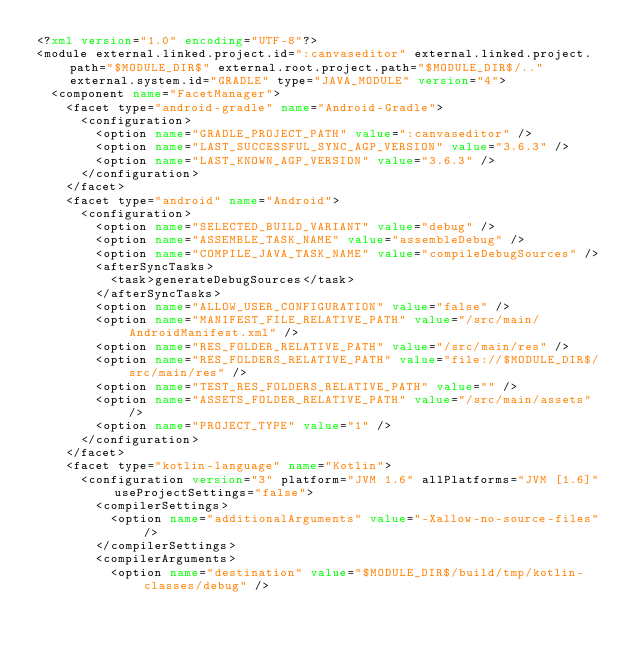Convert code to text. <code><loc_0><loc_0><loc_500><loc_500><_XML_><?xml version="1.0" encoding="UTF-8"?>
<module external.linked.project.id=":canvaseditor" external.linked.project.path="$MODULE_DIR$" external.root.project.path="$MODULE_DIR$/.." external.system.id="GRADLE" type="JAVA_MODULE" version="4">
  <component name="FacetManager">
    <facet type="android-gradle" name="Android-Gradle">
      <configuration>
        <option name="GRADLE_PROJECT_PATH" value=":canvaseditor" />
        <option name="LAST_SUCCESSFUL_SYNC_AGP_VERSION" value="3.6.3" />
        <option name="LAST_KNOWN_AGP_VERSION" value="3.6.3" />
      </configuration>
    </facet>
    <facet type="android" name="Android">
      <configuration>
        <option name="SELECTED_BUILD_VARIANT" value="debug" />
        <option name="ASSEMBLE_TASK_NAME" value="assembleDebug" />
        <option name="COMPILE_JAVA_TASK_NAME" value="compileDebugSources" />
        <afterSyncTasks>
          <task>generateDebugSources</task>
        </afterSyncTasks>
        <option name="ALLOW_USER_CONFIGURATION" value="false" />
        <option name="MANIFEST_FILE_RELATIVE_PATH" value="/src/main/AndroidManifest.xml" />
        <option name="RES_FOLDER_RELATIVE_PATH" value="/src/main/res" />
        <option name="RES_FOLDERS_RELATIVE_PATH" value="file://$MODULE_DIR$/src/main/res" />
        <option name="TEST_RES_FOLDERS_RELATIVE_PATH" value="" />
        <option name="ASSETS_FOLDER_RELATIVE_PATH" value="/src/main/assets" />
        <option name="PROJECT_TYPE" value="1" />
      </configuration>
    </facet>
    <facet type="kotlin-language" name="Kotlin">
      <configuration version="3" platform="JVM 1.6" allPlatforms="JVM [1.6]" useProjectSettings="false">
        <compilerSettings>
          <option name="additionalArguments" value="-Xallow-no-source-files" />
        </compilerSettings>
        <compilerArguments>
          <option name="destination" value="$MODULE_DIR$/build/tmp/kotlin-classes/debug" /></code> 